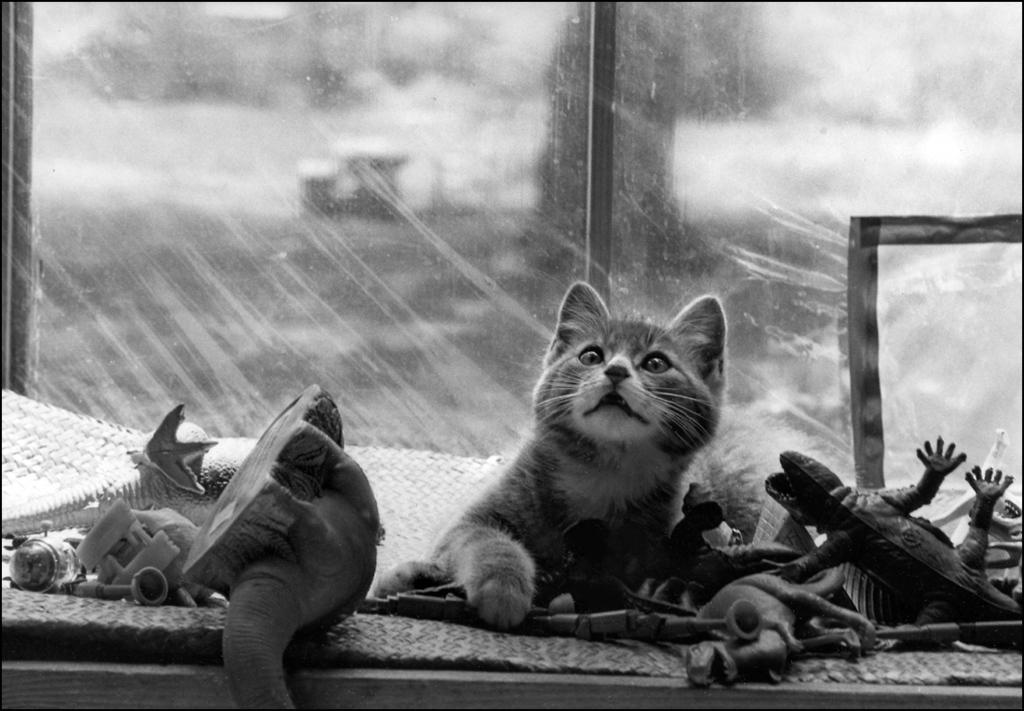What is the main subject in the image? There is a cat laying in the middle of the image. What else can be seen in the image besides the cat? There are toys of different animals in the image. Can you describe the window in the image? There is a glass window in the middle of the image. How does the cat help to clear the fog in the image? There is no fog present in the image, and the cat is not performing any actions related to clearing fog. 